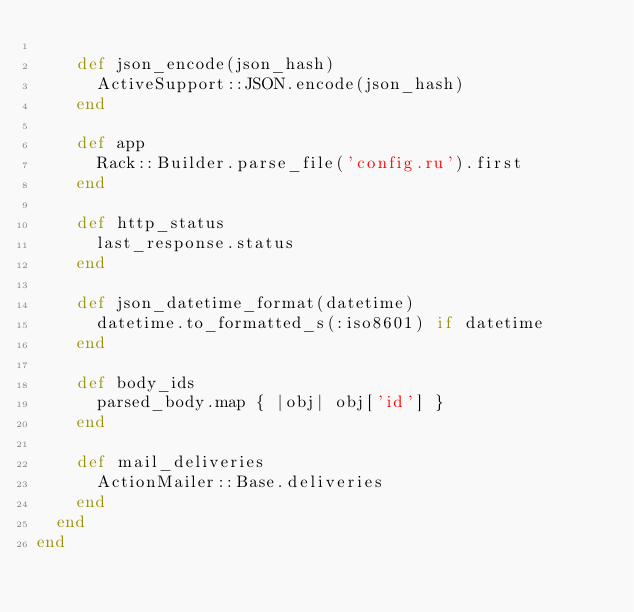<code> <loc_0><loc_0><loc_500><loc_500><_Ruby_>
    def json_encode(json_hash)
      ActiveSupport::JSON.encode(json_hash)
    end

    def app
      Rack::Builder.parse_file('config.ru').first
    end

    def http_status
      last_response.status
    end

    def json_datetime_format(datetime)
      datetime.to_formatted_s(:iso8601) if datetime
    end

    def body_ids
      parsed_body.map { |obj| obj['id'] }
    end

    def mail_deliveries
      ActionMailer::Base.deliveries
    end
  end
end</code> 